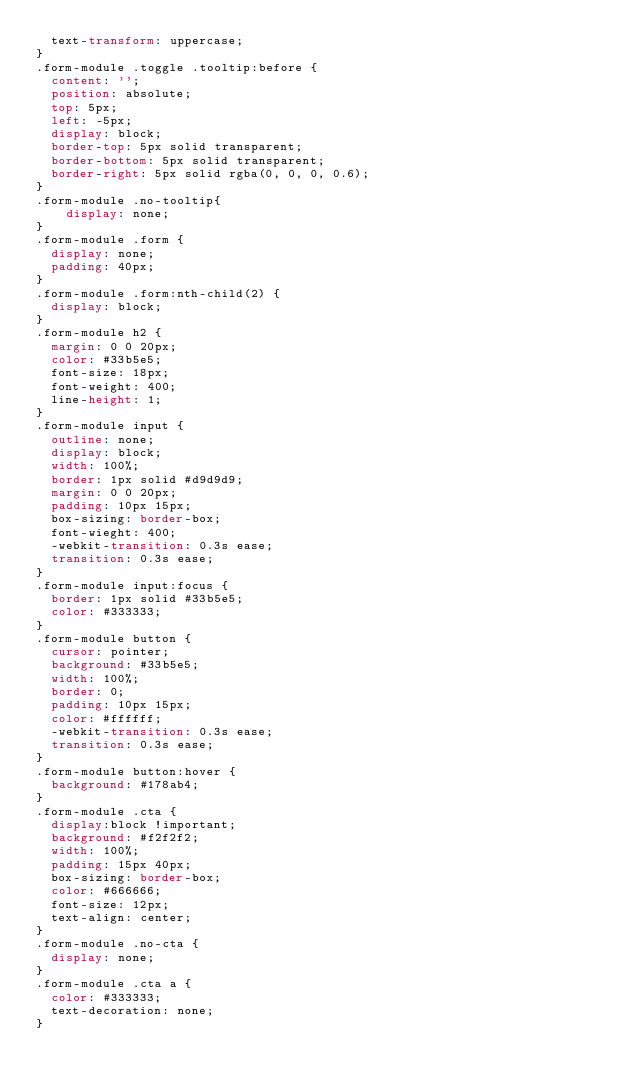<code> <loc_0><loc_0><loc_500><loc_500><_CSS_>  text-transform: uppercase;
}
.form-module .toggle .tooltip:before {
  content: '';
  position: absolute;
  top: 5px;
  left: -5px;
  display: block;
  border-top: 5px solid transparent;
  border-bottom: 5px solid transparent;
  border-right: 5px solid rgba(0, 0, 0, 0.6);
}
.form-module .no-tooltip{
	display: none;
}
.form-module .form {
  display: none;
  padding: 40px;
}
.form-module .form:nth-child(2) {
  display: block;
}
.form-module h2 {
  margin: 0 0 20px;
  color: #33b5e5;
  font-size: 18px;
  font-weight: 400;
  line-height: 1;
}
.form-module input {
  outline: none;
  display: block;
  width: 100%;
  border: 1px solid #d9d9d9;
  margin: 0 0 20px;
  padding: 10px 15px;
  box-sizing: border-box;
  font-wieght: 400;
  -webkit-transition: 0.3s ease;
  transition: 0.3s ease;
}
.form-module input:focus {
  border: 1px solid #33b5e5;
  color: #333333;
}
.form-module button {
  cursor: pointer;
  background: #33b5e5;
  width: 100%;
  border: 0;
  padding: 10px 15px;
  color: #ffffff;
  -webkit-transition: 0.3s ease;
  transition: 0.3s ease;
}
.form-module button:hover {
  background: #178ab4;
}
.form-module .cta {
  display:block !important;
  background: #f2f2f2;
  width: 100%;
  padding: 15px 40px;
  box-sizing: border-box;
  color: #666666;
  font-size: 12px;
  text-align: center;
}
.form-module .no-cta {
  display: none;
}
.form-module .cta a {
  color: #333333;
  text-decoration: none;
}
</code> 